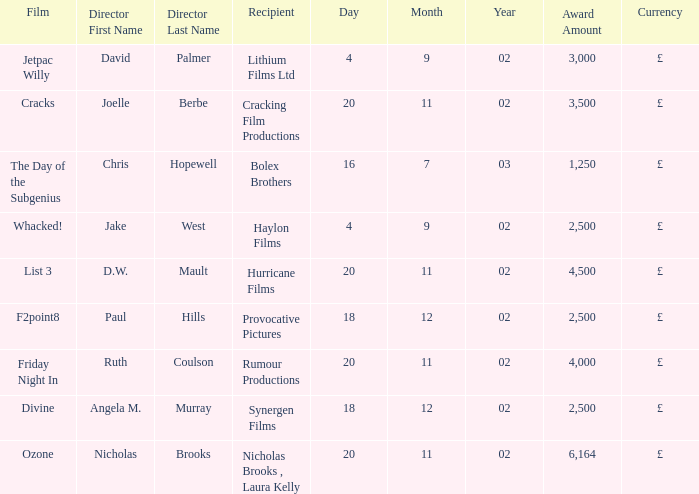Who won an award of £3,000 on 4/9/02? Lithium Films Ltd. 